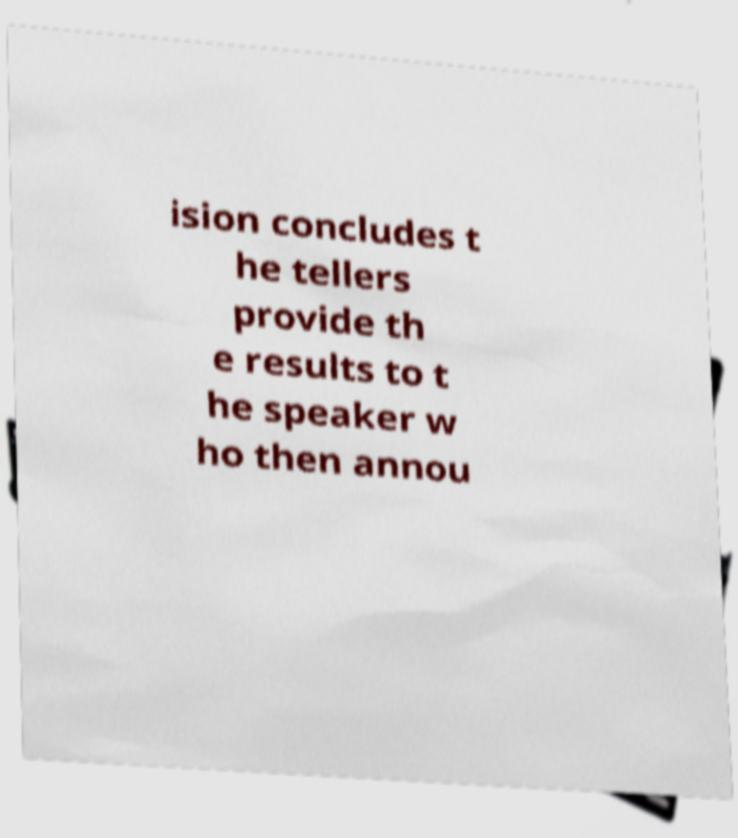There's text embedded in this image that I need extracted. Can you transcribe it verbatim? ision concludes t he tellers provide th e results to t he speaker w ho then annou 